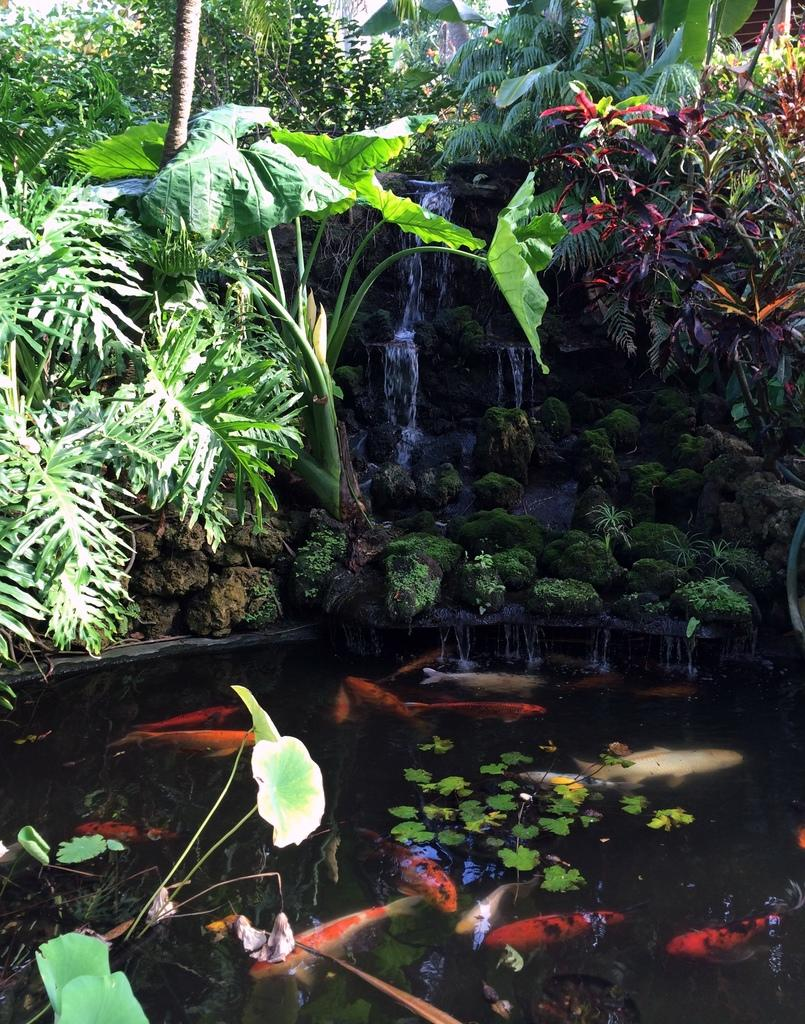What is present in the pond in the image? There are leaves and fishes in the pond. What can be seen in the background of the image? The background of the image includes plants, trees, a rock, and a waterfall. Can you describe the vegetation on the rocks? There is grass on the rocks. What type of riddle can be solved by observing the seed in the image? There is no seed present in the image, so it cannot be used to solve a riddle. 